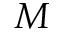Convert formula to latex. <formula><loc_0><loc_0><loc_500><loc_500>M</formula> 